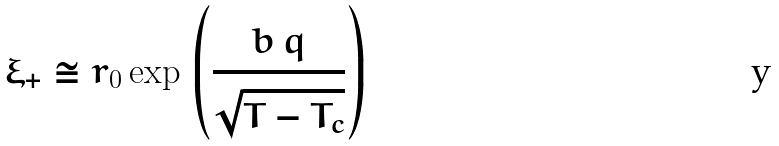Convert formula to latex. <formula><loc_0><loc_0><loc_500><loc_500>\xi _ { + } \cong r _ { 0 } \exp \, \left ( \frac { b \, q } { \sqrt { T - T _ { c } } } \right )</formula> 